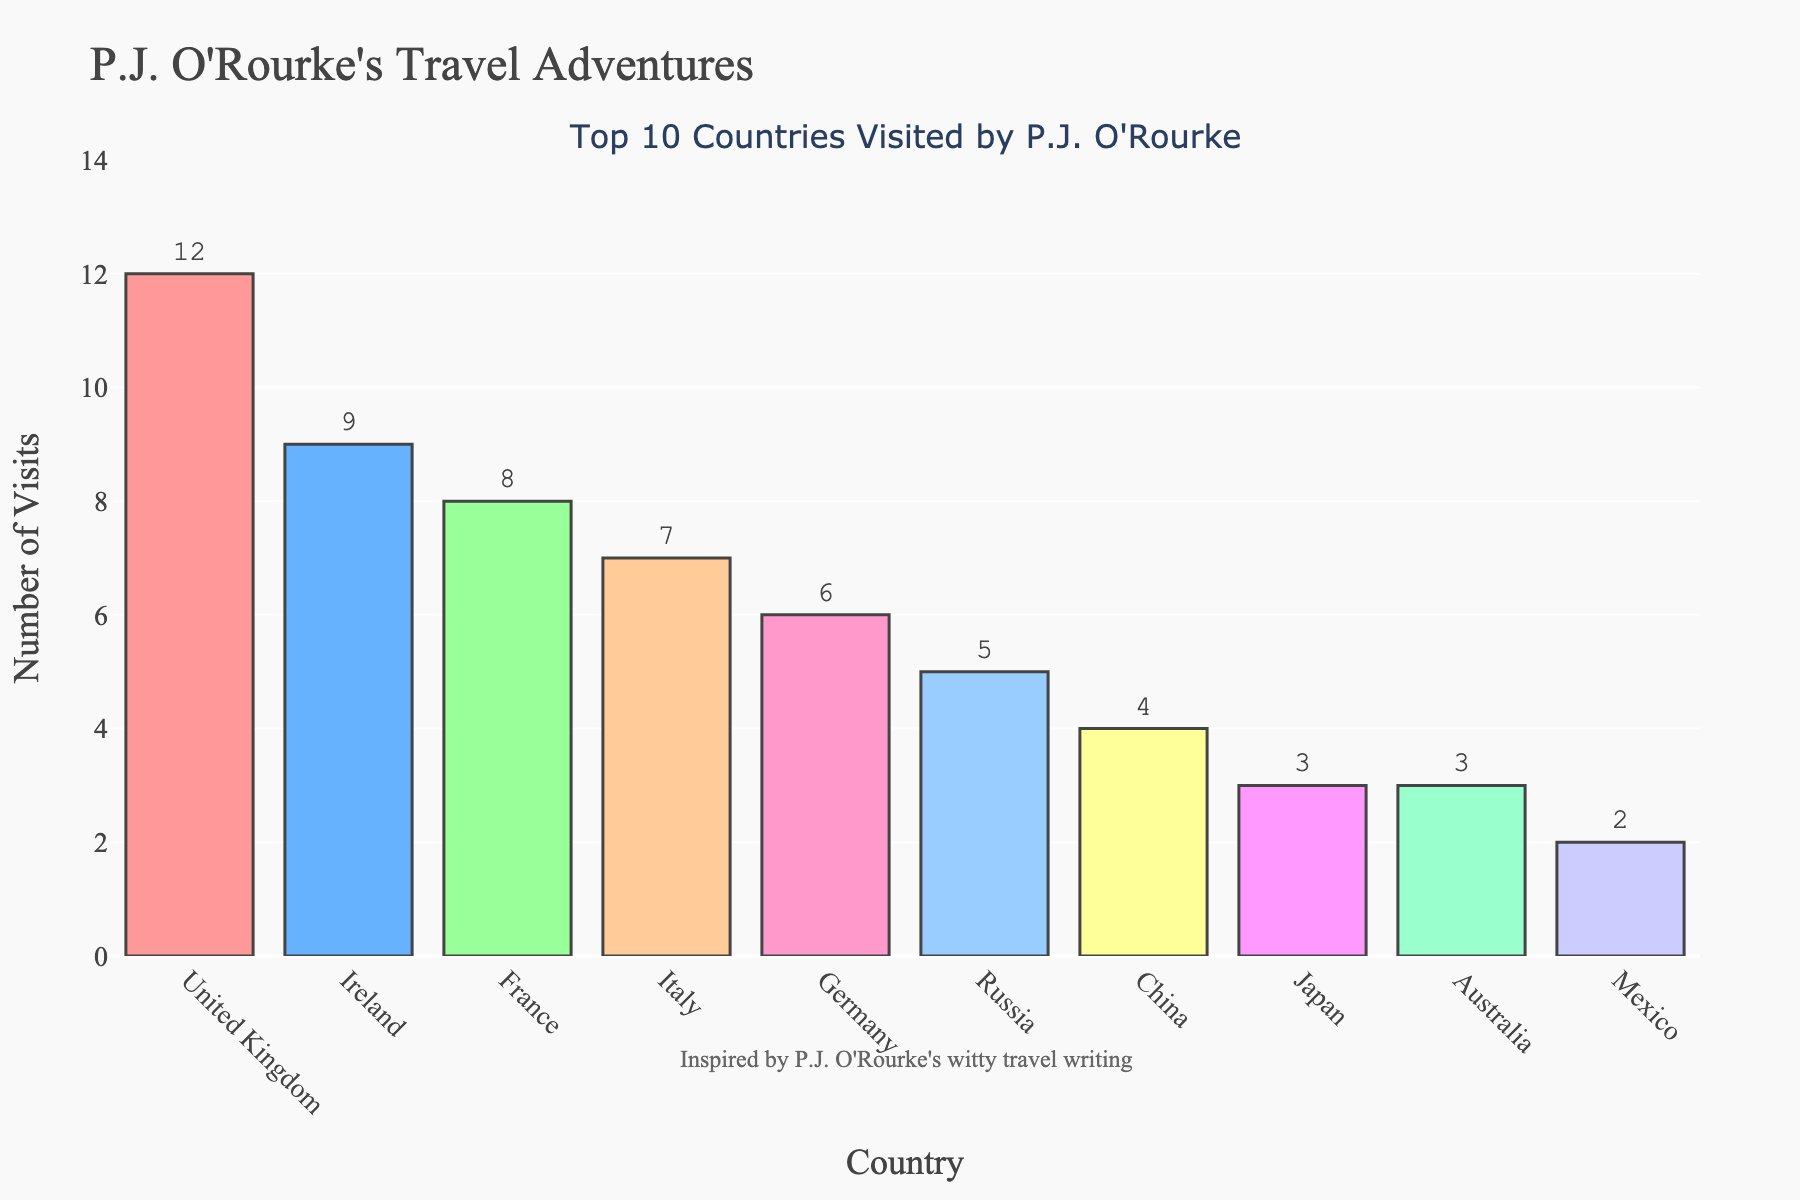What's the country most frequently visited by P.J. O'Rourke? Look at the bar with the greatest height on the plot, which represents the largest number of visits. The bar for the United Kingdom stands out as the tallest, indicating it was visited 12 times.
Answer: United Kingdom How many more times did P.J. O'Rourke visit Italy compared to Mexico? Find the bars representing Italy and Mexico, and note their heights. Italy has 7 visits, and Mexico has 2 visits. Subtract Mexico's visits from Italy's visits: 7 - 2 = 5.
Answer: 5 times Which countries did P.J. O'Rourke visit equally as many times? Locate bars of equal height. The bars for Japan and Australia are of equal height, each with 3 visits.
Answer: Japan and Australia What is the combined number of visits for France and Germany? Identify the heights of the bars corresponding to France and Germany. France has 8 visits, and Germany has 6 visits. Add these together: 8 + 6 = 14.
Answer: 14 visits Compare the visits to Russia and China. Did P.J. O'Rourke visit one of these countries more frequently? Compare the heights of the bars for Russia and China. The bar for Russia is higher with 5 visits, compared to China's 4 visits.
Answer: Russia What's the average number of visits across all the top 10 countries visited by P.J. O'Rourke? Sum the visits for all countries (12 + 9 + 8 + 7 + 6 + 5 + 4 + 3 + 3 + 2 = 59). Divide this sum by the number of countries: 59 / 10 = 5.9.
Answer: 5.9 visits Which country with a visit count of 4 is represented in the chart? Look for the bar with a height of 4. This corresponds to the country of China.
Answer: China Identify the two countries P.J. O'Rourke visited less than 4 times. Observe the bars with heights less than 4. The countries are Japan and Mexico, with 3 and 2 visits respectively.
Answer: Japan and Mexico Of the countries listed, which bar has the most distinct color and number of visits? Notice the distinct coloring and count the visits along the corresponding bar. The bar for the United Kingdom is notably colored in red and has 12 visits.
Answer: United Kingdom 